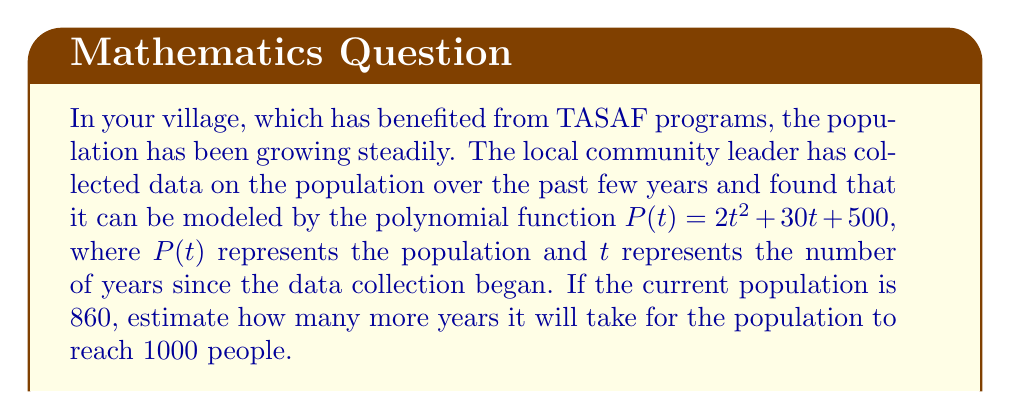Teach me how to tackle this problem. To solve this problem, we need to follow these steps:

1) First, we need to find the current value of $t$. We know that the current population is 860, so we can set up the equation:

   $860 = 2t^2 + 30t + 500$

2) Rearrange the equation:

   $2t^2 + 30t - 360 = 0$

3) This is a quadratic equation. We can solve it using the quadratic formula:

   $t = \frac{-b \pm \sqrt{b^2 - 4ac}}{2a}$

   Where $a=2$, $b=30$, and $c=-360$

4) Plugging in these values:

   $t = \frac{-30 \pm \sqrt{30^2 - 4(2)(-360)}}{2(2)}$
   
   $= \frac{-30 \pm \sqrt{900 + 2880}}{4}$
   
   $= \frac{-30 \pm \sqrt{3780}}{4}$
   
   $= \frac{-30 \pm 61.48}{4}$

5) This gives us two solutions: $t \approx 7.87$ or $t \approx -9.37$. Since time cannot be negative in this context, we take the positive solution. So, the current time is approximately 7.87 years since data collection began.

6) Now, we need to find when the population will reach 1000. We set up a new equation:

   $1000 = 2t^2 + 30t + 500$

7) Rearrange:

   $2t^2 + 30t - 500 = 0$

8) Solve using the quadratic formula again:

   $t = \frac{-30 \pm \sqrt{30^2 - 4(2)(-500)}}{2(2)}$
   
   $= \frac{-30 \pm \sqrt{900 + 4000}}{4}$
   
   $= \frac{-30 \pm \sqrt{4900}}{4}$
   
   $= \frac{-30 \pm 70}{4}$

9) This gives us $t = 10$ or $t = -20$. Again, we take the positive solution.

10) The population will reach 1000 after 10 years from the start of data collection.

11) To find how many more years from now, we subtract the current time:

    $10 - 7.87 \approx 2.13$ years

Therefore, it will take approximately 2.13 more years for the population to reach 1000 people.
Answer: It will take approximately 2.13 years for the village population to grow from 860 to 1000 people. 